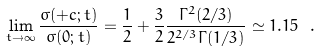<formula> <loc_0><loc_0><loc_500><loc_500>\lim _ { t \to \infty } \frac { \sigma ( + c ; t ) } { \sigma ( 0 ; t ) } = \frac { 1 } { 2 } + \frac { 3 } { 2 } \frac { \Gamma ^ { 2 } ( 2 / 3 ) } { 2 ^ { 2 / 3 } \Gamma ( 1 / 3 ) } \simeq 1 . 1 5 \ .</formula> 